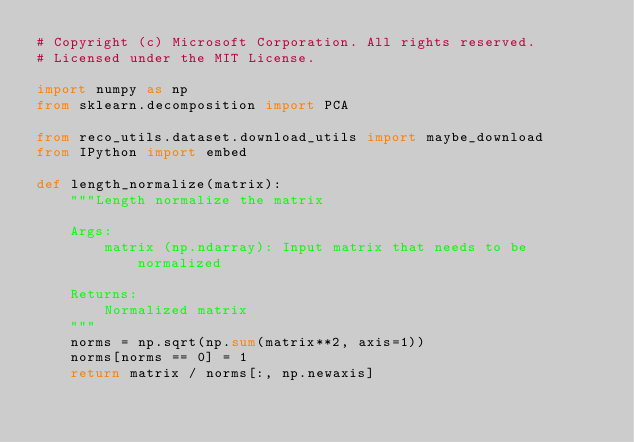<code> <loc_0><loc_0><loc_500><loc_500><_Python_># Copyright (c) Microsoft Corporation. All rights reserved.
# Licensed under the MIT License.

import numpy as np
from sklearn.decomposition import PCA

from reco_utils.dataset.download_utils import maybe_download
from IPython import embed

def length_normalize(matrix):
    """Length normalize the matrix

    Args:
        matrix (np.ndarray): Input matrix that needs to be normalized

    Returns:
        Normalized matrix
    """
    norms = np.sqrt(np.sum(matrix**2, axis=1))
    norms[norms == 0] = 1
    return matrix / norms[:, np.newaxis]

</code> 